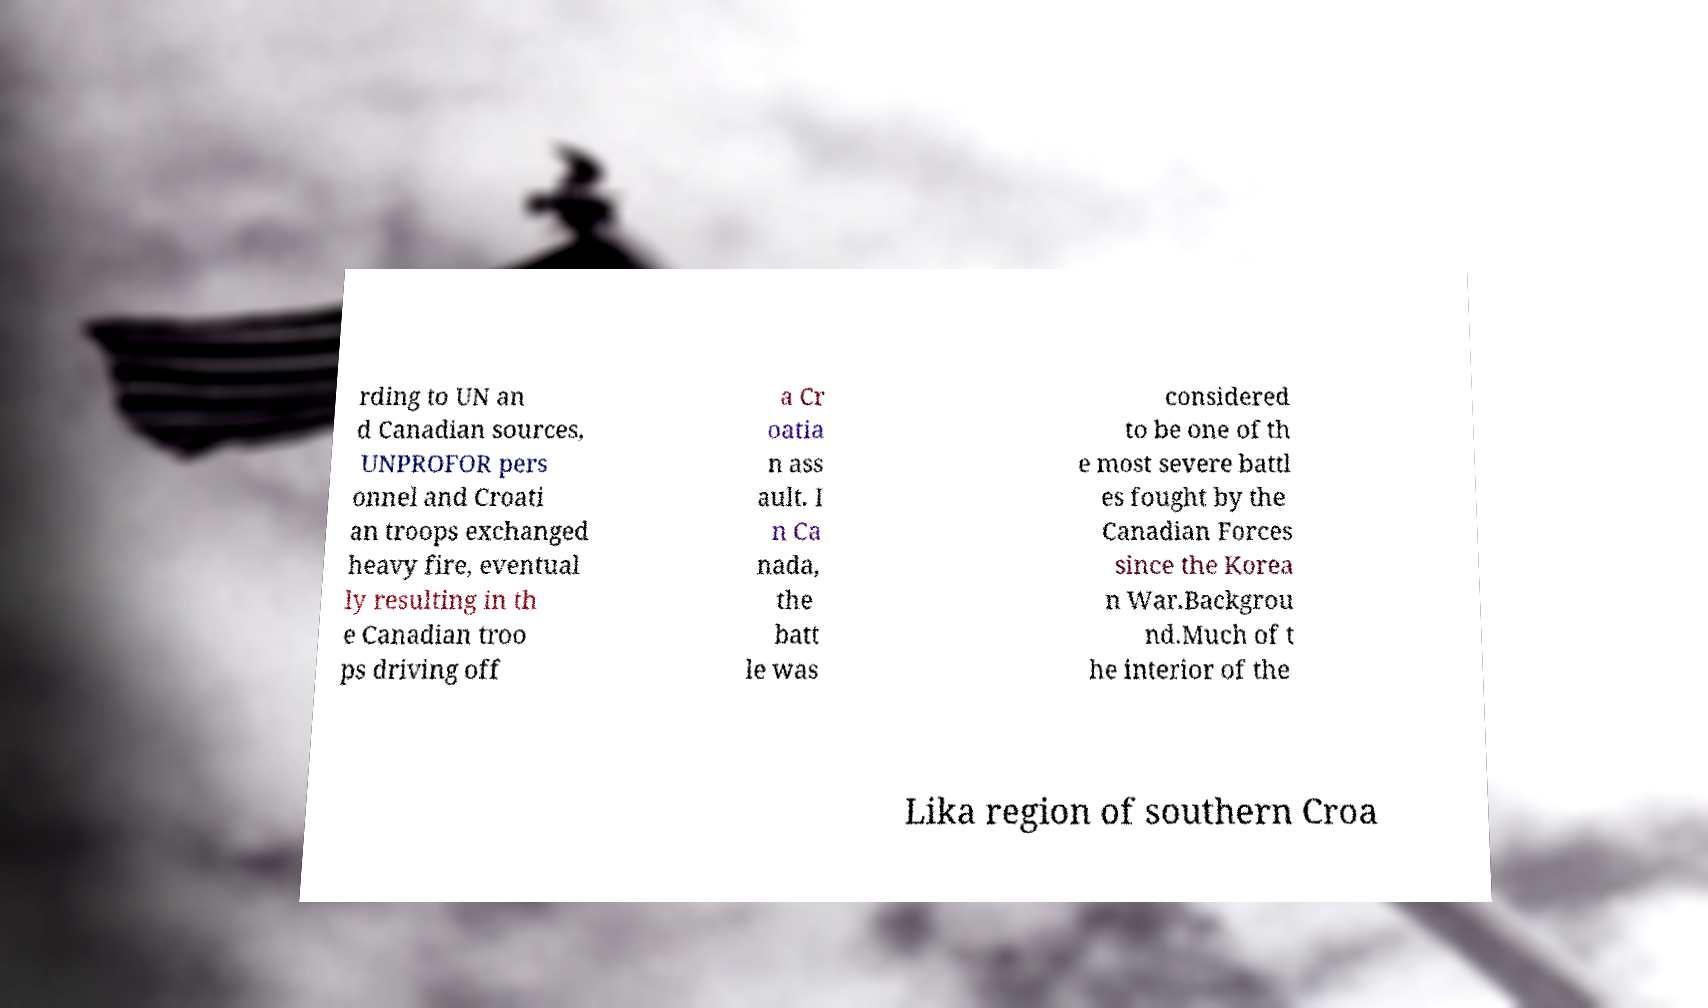For documentation purposes, I need the text within this image transcribed. Could you provide that? rding to UN an d Canadian sources, UNPROFOR pers onnel and Croati an troops exchanged heavy fire, eventual ly resulting in th e Canadian troo ps driving off a Cr oatia n ass ault. I n Ca nada, the batt le was considered to be one of th e most severe battl es fought by the Canadian Forces since the Korea n War.Backgrou nd.Much of t he interior of the Lika region of southern Croa 